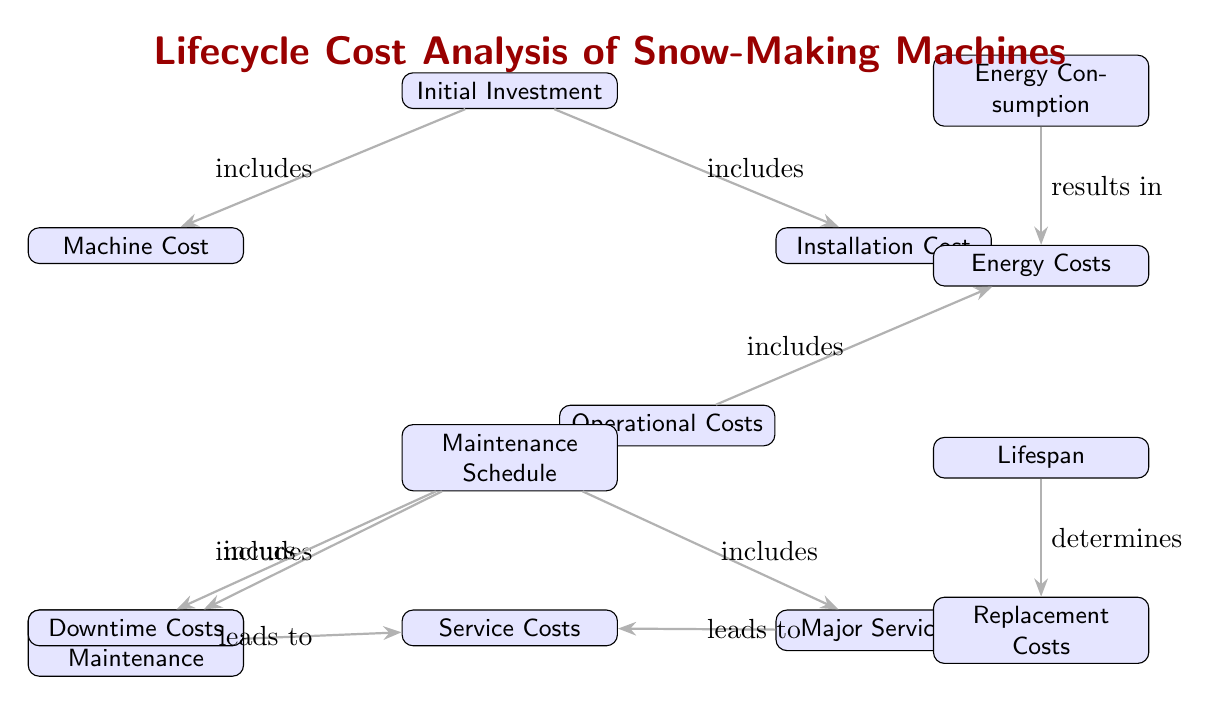What are the two components included in the initial investment? The diagram shows that the initial investment includes two components: machine cost and installation cost, indicated by the arrows leading from the initial investment node towards these components.
Answer: Machine Cost, Installation Cost What does the maintenance schedule incur? According to the diagram, the maintenance schedule incurs downtime costs, as indicated by the arrow from the maintenance schedule to the downtime costs node.
Answer: Downtime Costs What leads to service costs from routine maintenance? The diagram shows an arrow from routine maintenance to service costs, indicating that routine maintenance leads to these service costs.
Answer: Leads to How does energy consumption affect energy costs? The relationship in the diagram indicates that energy consumption directly results in energy costs, as represented by the arrow leading from energy consumption to energy costs.
Answer: Results in How many total nodes are in the diagram? To find the total number of nodes, count each of the distinct boxes in the diagram, which gives a total of eight nodes.
Answer: Eight What determines the replacement costs? The diagram indicates that the lifespan determines the replacement costs, shown by an arrow leading from the lifespan node to the replacement costs node.
Answer: Lifespan What includes operational costs? Through examining the diagram, we see that energy costs include operational costs, as indicated by the arrow from operational costs to energy costs.
Answer: Includes Which two types of maintenance are included in the maintenance schedule? The two types of maintenance included in the maintenance schedule are routine maintenance and major servicing, which are both shown as children nodes of the maintenance schedule in the diagram.
Answer: Routine Maintenance, Major Servicing What is the relationship between operational costs and energy costs? The diagram indicates that operational costs include energy costs, as seen from the arrow that points from operational costs to energy costs.
Answer: Includes 